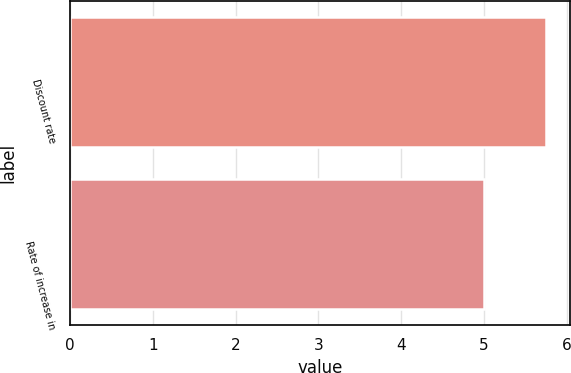Convert chart. <chart><loc_0><loc_0><loc_500><loc_500><bar_chart><fcel>Discount rate<fcel>Rate of increase in<nl><fcel>5.75<fcel>5<nl></chart> 